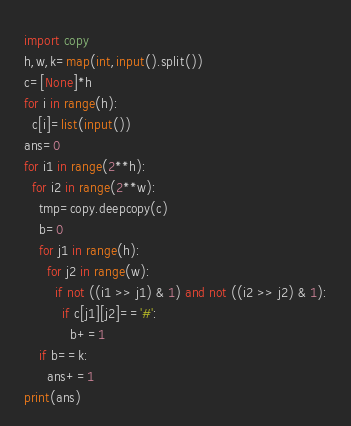<code> <loc_0><loc_0><loc_500><loc_500><_Python_>import copy
h,w,k=map(int,input().split())
c=[None]*h
for i in range(h):
  c[i]=list(input())
ans=0
for i1 in range(2**h):
  for i2 in range(2**w):
    tmp=copy.deepcopy(c)
    b=0
    for j1 in range(h):
      for j2 in range(w):
      	if not ((i1 >> j1) & 1) and not ((i2 >> j2) & 1):
          if c[j1][j2]=='#':
            b+=1
    if b==k:
      ans+=1
print(ans)</code> 